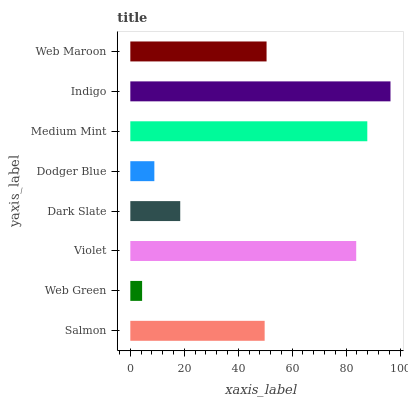Is Web Green the minimum?
Answer yes or no. Yes. Is Indigo the maximum?
Answer yes or no. Yes. Is Violet the minimum?
Answer yes or no. No. Is Violet the maximum?
Answer yes or no. No. Is Violet greater than Web Green?
Answer yes or no. Yes. Is Web Green less than Violet?
Answer yes or no. Yes. Is Web Green greater than Violet?
Answer yes or no. No. Is Violet less than Web Green?
Answer yes or no. No. Is Web Maroon the high median?
Answer yes or no. Yes. Is Salmon the low median?
Answer yes or no. Yes. Is Dodger Blue the high median?
Answer yes or no. No. Is Indigo the low median?
Answer yes or no. No. 